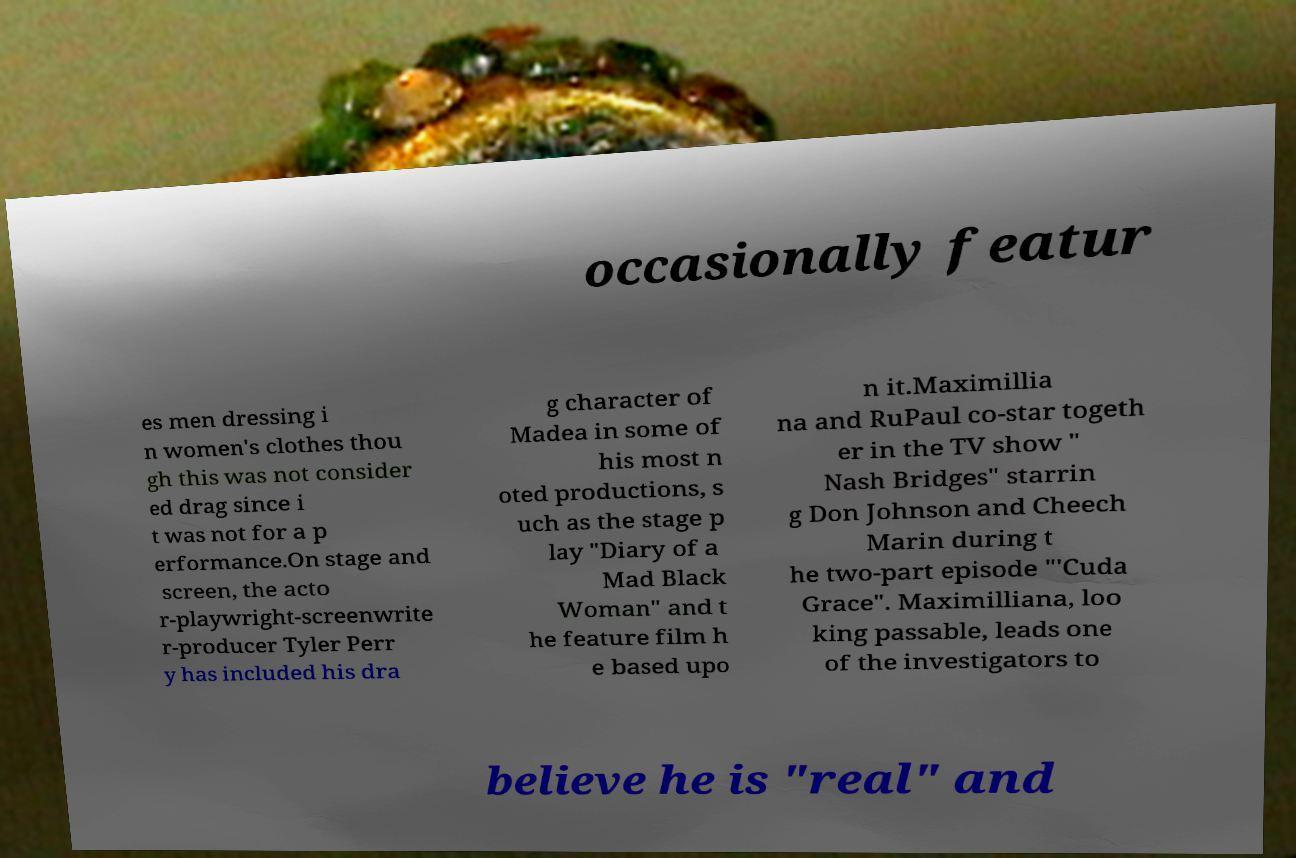I need the written content from this picture converted into text. Can you do that? occasionally featur es men dressing i n women's clothes thou gh this was not consider ed drag since i t was not for a p erformance.On stage and screen, the acto r-playwright-screenwrite r-producer Tyler Perr y has included his dra g character of Madea in some of his most n oted productions, s uch as the stage p lay "Diary of a Mad Black Woman" and t he feature film h e based upo n it.Maximillia na and RuPaul co-star togeth er in the TV show " Nash Bridges" starrin g Don Johnson and Cheech Marin during t he two-part episode "'Cuda Grace". Maximilliana, loo king passable, leads one of the investigators to believe he is "real" and 